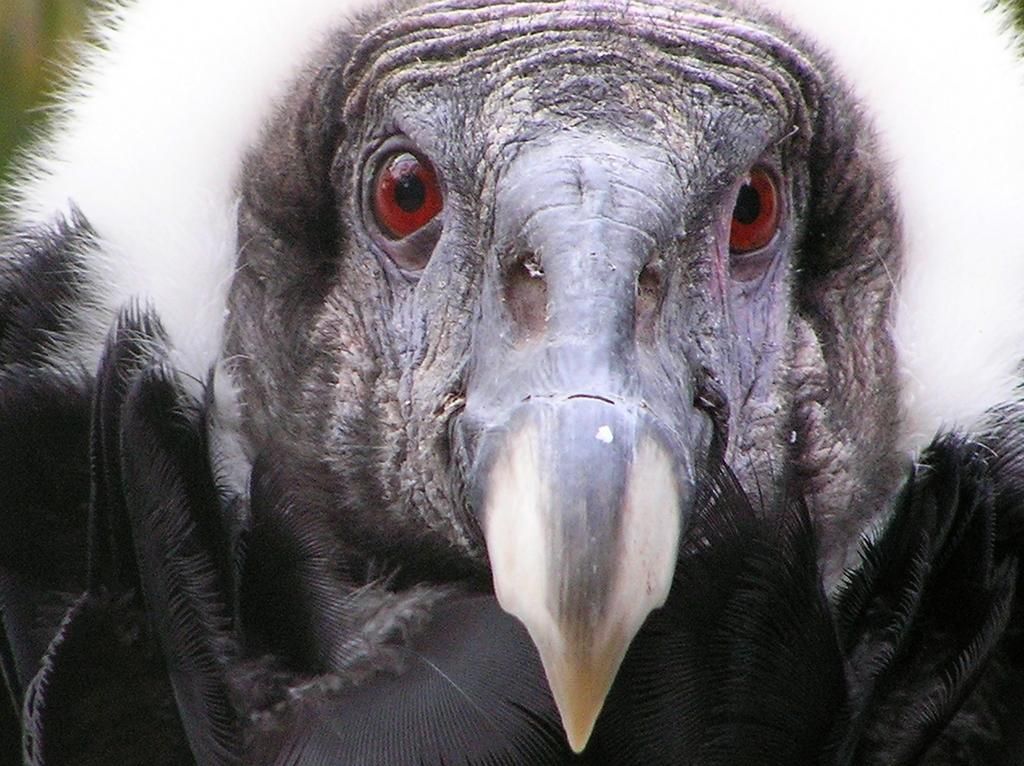What type of animal is in the image? There is an eagle in the image. What color is the eagle? The eagle is black in color. What is unique about the eagle's eyes? The eagle has two red eyes. What flavor of toothpaste is the eagle using in the image? There is no toothpaste present in the image, and the eagle is not using any toothpaste. 